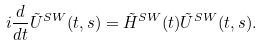<formula> <loc_0><loc_0><loc_500><loc_500>i \frac { d } { d t } { \tilde { U } } ^ { S W } ( t , s ) = { \tilde { H } } ^ { S W } ( t ) { \tilde { U } } ^ { S W } ( t , s ) .</formula> 